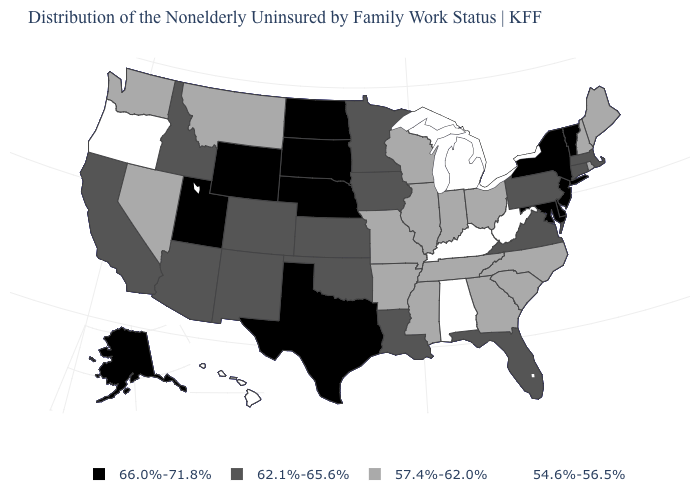What is the value of Maryland?
Keep it brief. 66.0%-71.8%. Name the states that have a value in the range 54.6%-56.5%?
Give a very brief answer. Alabama, Hawaii, Kentucky, Michigan, Oregon, West Virginia. Is the legend a continuous bar?
Quick response, please. No. Name the states that have a value in the range 57.4%-62.0%?
Answer briefly. Arkansas, Georgia, Illinois, Indiana, Maine, Mississippi, Missouri, Montana, Nevada, New Hampshire, North Carolina, Ohio, Rhode Island, South Carolina, Tennessee, Washington, Wisconsin. Which states have the highest value in the USA?
Keep it brief. Alaska, Delaware, Maryland, Nebraska, New Jersey, New York, North Dakota, South Dakota, Texas, Utah, Vermont, Wyoming. Does Iowa have a lower value than Mississippi?
Quick response, please. No. What is the value of Hawaii?
Short answer required. 54.6%-56.5%. How many symbols are there in the legend?
Be succinct. 4. Does West Virginia have the lowest value in the USA?
Write a very short answer. Yes. What is the value of Minnesota?
Quick response, please. 62.1%-65.6%. What is the value of Georgia?
Be succinct. 57.4%-62.0%. What is the value of North Carolina?
Be succinct. 57.4%-62.0%. Does the map have missing data?
Short answer required. No. Name the states that have a value in the range 66.0%-71.8%?
Be succinct. Alaska, Delaware, Maryland, Nebraska, New Jersey, New York, North Dakota, South Dakota, Texas, Utah, Vermont, Wyoming. Name the states that have a value in the range 54.6%-56.5%?
Give a very brief answer. Alabama, Hawaii, Kentucky, Michigan, Oregon, West Virginia. 